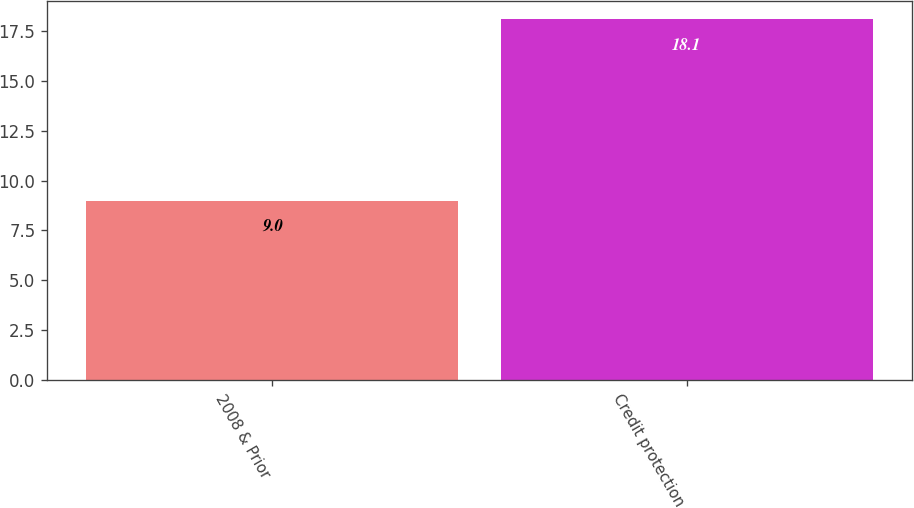Convert chart to OTSL. <chart><loc_0><loc_0><loc_500><loc_500><bar_chart><fcel>2008 & Prior<fcel>Credit protection<nl><fcel>9<fcel>18.1<nl></chart> 